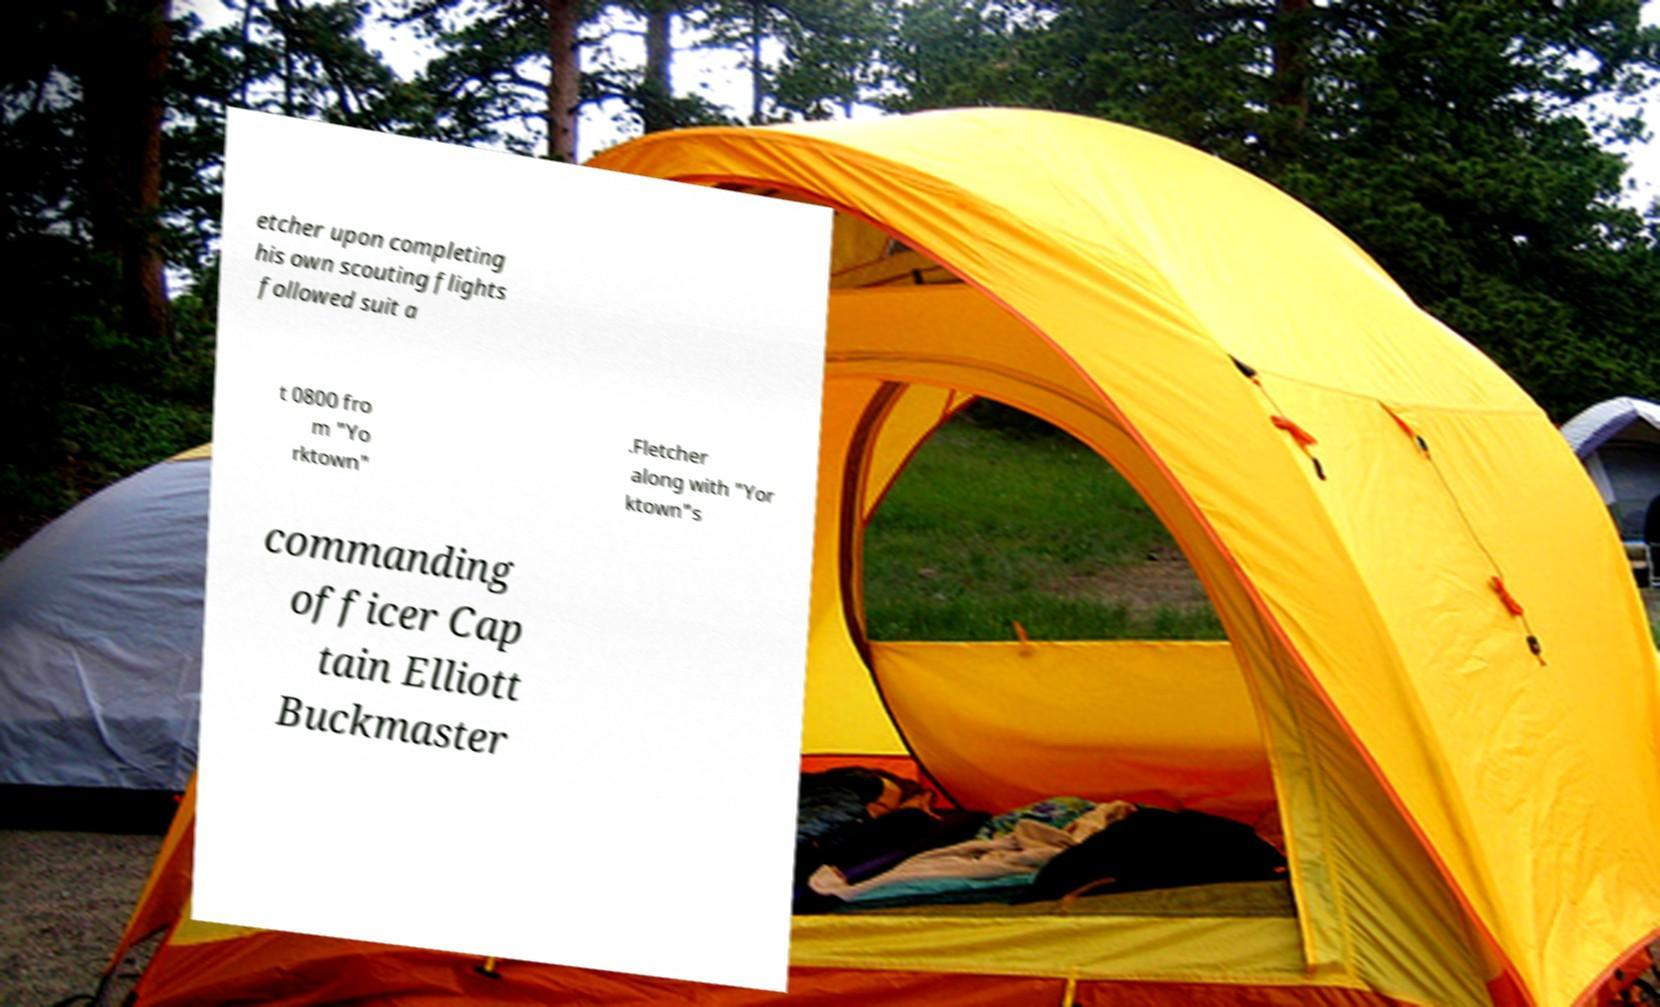Could you assist in decoding the text presented in this image and type it out clearly? etcher upon completing his own scouting flights followed suit a t 0800 fro m "Yo rktown" .Fletcher along with "Yor ktown"s commanding officer Cap tain Elliott Buckmaster 